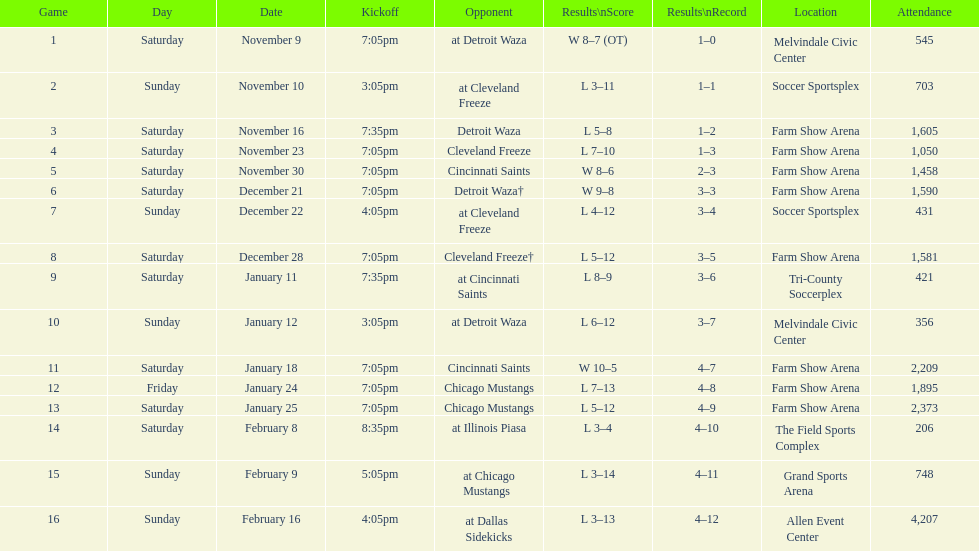How many games did the harrisburg heat lose to the cleveland freeze in total. 4. 